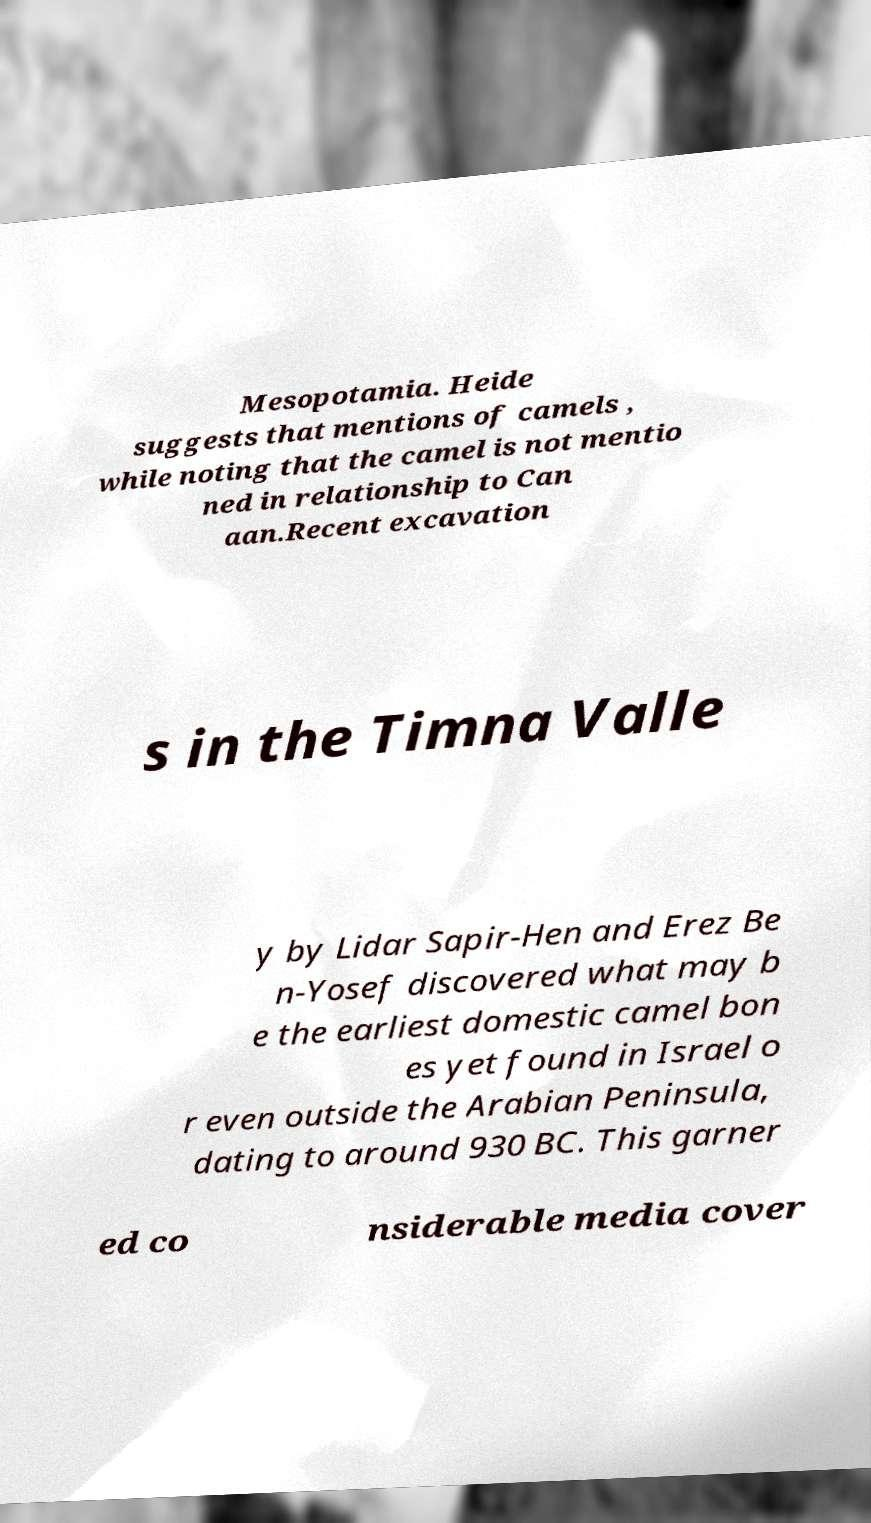Can you read and provide the text displayed in the image?This photo seems to have some interesting text. Can you extract and type it out for me? Mesopotamia. Heide suggests that mentions of camels , while noting that the camel is not mentio ned in relationship to Can aan.Recent excavation s in the Timna Valle y by Lidar Sapir-Hen and Erez Be n-Yosef discovered what may b e the earliest domestic camel bon es yet found in Israel o r even outside the Arabian Peninsula, dating to around 930 BC. This garner ed co nsiderable media cover 